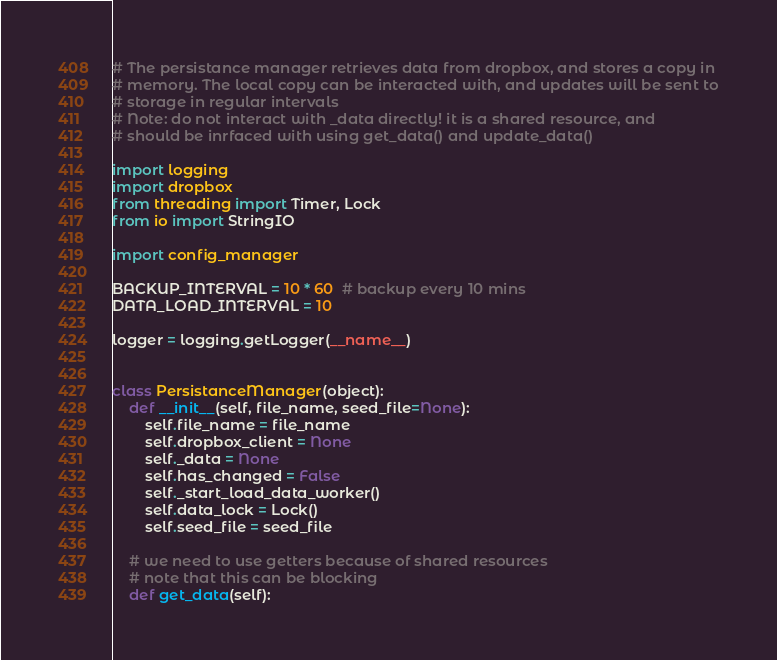<code> <loc_0><loc_0><loc_500><loc_500><_Python_># The persistance manager retrieves data from dropbox, and stores a copy in
# memory. The local copy can be interacted with, and updates will be sent to
# storage in regular intervals
# Note: do not interact with _data directly! it is a shared resource, and
# should be inrfaced with using get_data() and update_data()

import logging
import dropbox
from threading import Timer, Lock
from io import StringIO

import config_manager

BACKUP_INTERVAL = 10 * 60  # backup every 10 mins
DATA_LOAD_INTERVAL = 10

logger = logging.getLogger(__name__)


class PersistanceManager(object):
    def __init__(self, file_name, seed_file=None):
        self.file_name = file_name
        self.dropbox_client = None
        self._data = None
        self.has_changed = False
        self._start_load_data_worker()
        self.data_lock = Lock()
        self.seed_file = seed_file

    # we need to use getters because of shared resources
    # note that this can be blocking
    def get_data(self):</code> 